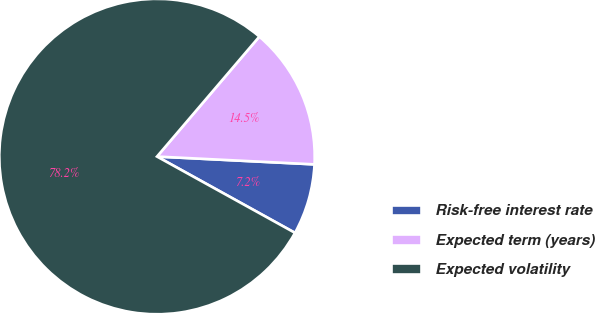<chart> <loc_0><loc_0><loc_500><loc_500><pie_chart><fcel>Risk-free interest rate<fcel>Expected term (years)<fcel>Expected volatility<nl><fcel>7.25%<fcel>14.55%<fcel>78.21%<nl></chart> 